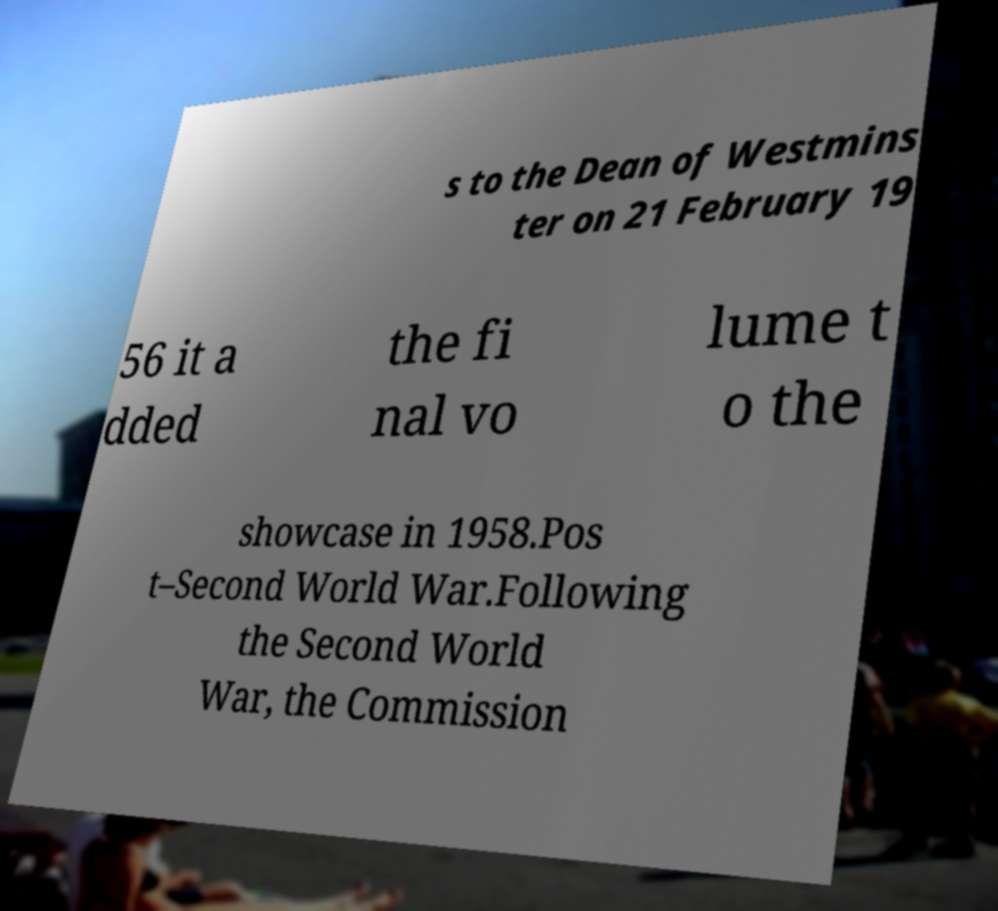Could you extract and type out the text from this image? s to the Dean of Westmins ter on 21 February 19 56 it a dded the fi nal vo lume t o the showcase in 1958.Pos t–Second World War.Following the Second World War, the Commission 